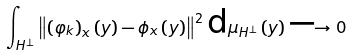<formula> <loc_0><loc_0><loc_500><loc_500>\int _ { H ^ { \perp } } \left \| \left ( \varphi _ { k } \right ) _ { x } \left ( y \right ) - \phi _ { x } \left ( y \right ) \right \| ^ { 2 } \text {d} \mu _ { H ^ { \perp } } \left ( y \right ) \longrightarrow 0</formula> 